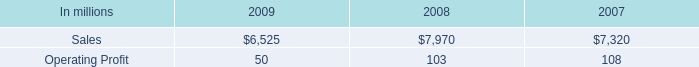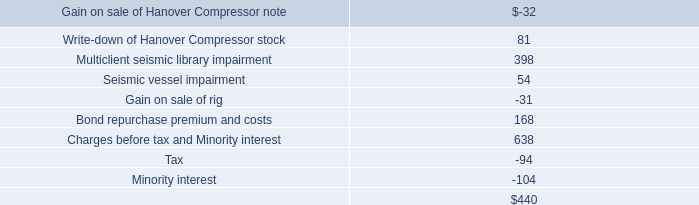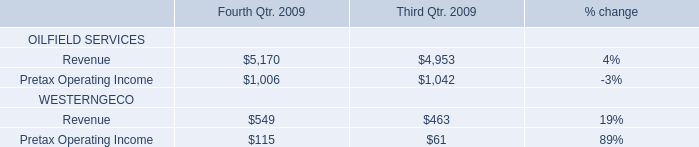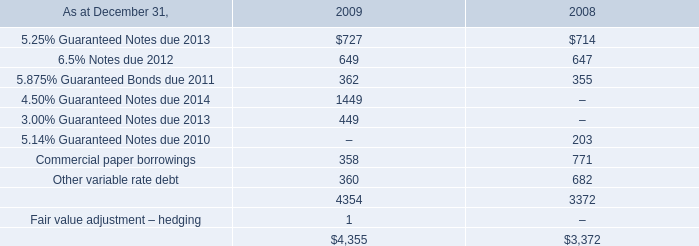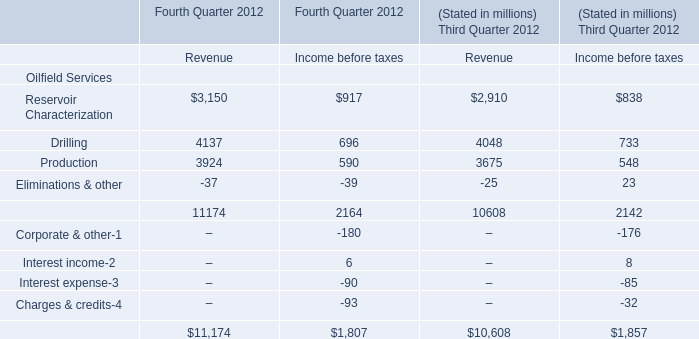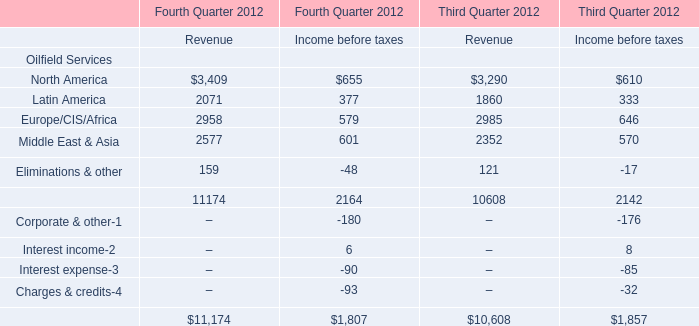What's the sum of all Revenue that are positive in 2012 for Third Quarter 2012? 
Computations: ((((3290 + 1860) + 2985) + 2352) + 121)
Answer: 10608.0. 